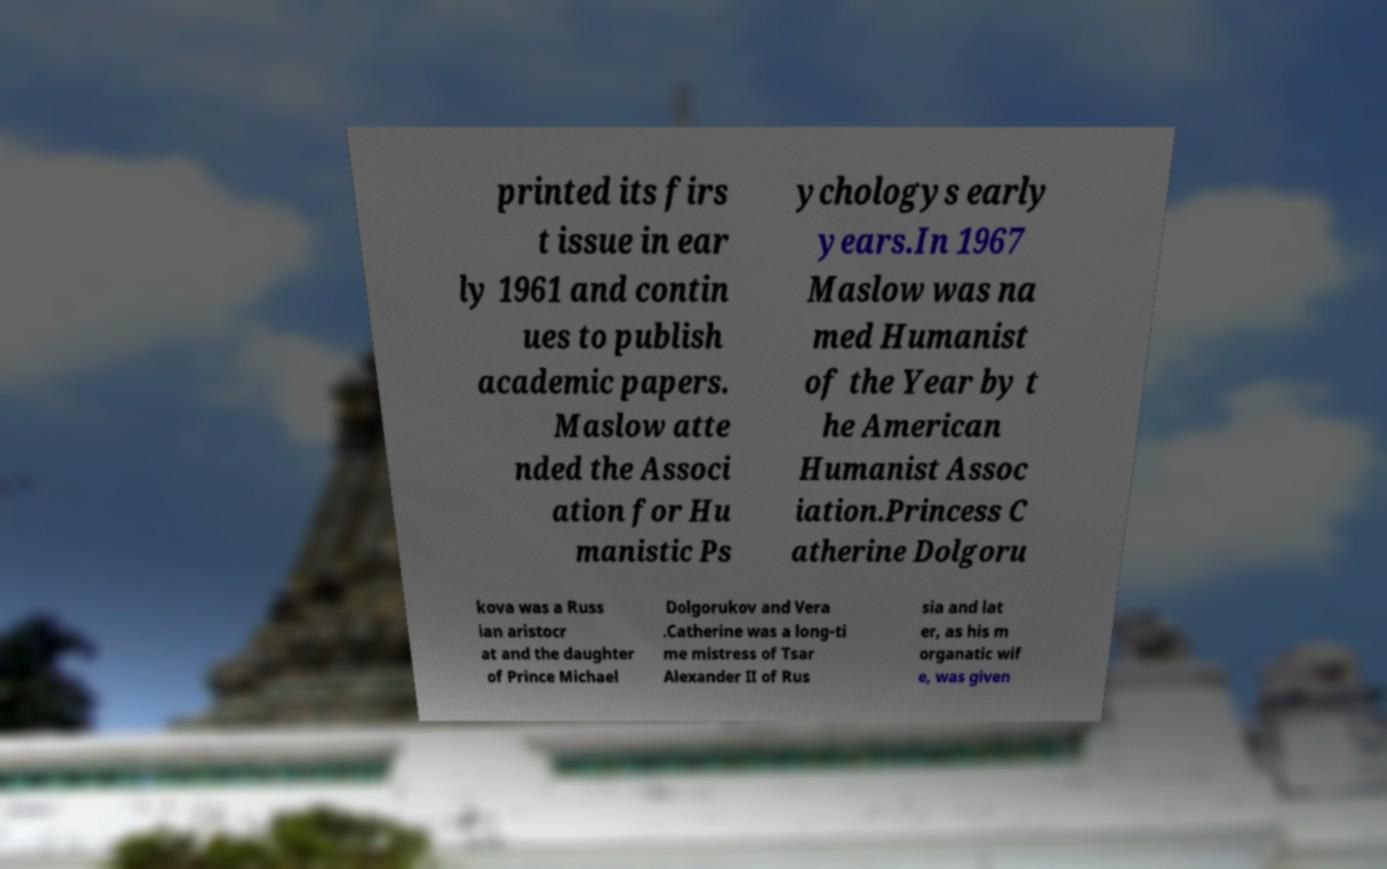What messages or text are displayed in this image? I need them in a readable, typed format. printed its firs t issue in ear ly 1961 and contin ues to publish academic papers. Maslow atte nded the Associ ation for Hu manistic Ps ychologys early years.In 1967 Maslow was na med Humanist of the Year by t he American Humanist Assoc iation.Princess C atherine Dolgoru kova was a Russ ian aristocr at and the daughter of Prince Michael Dolgorukov and Vera .Catherine was a long-ti me mistress of Tsar Alexander II of Rus sia and lat er, as his m organatic wif e, was given 